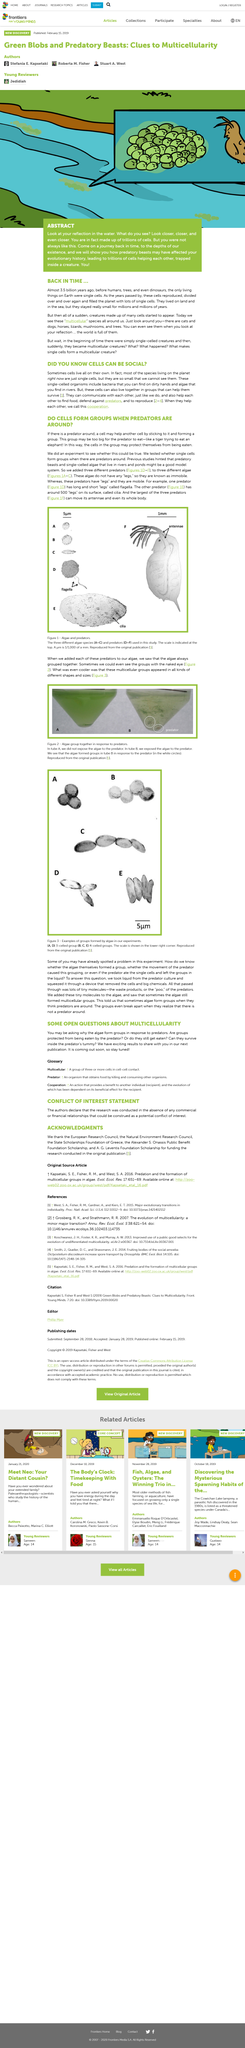Point out several critical features in this image. As depicted in Figure 1, three predators are visually represented. In Figure 1, three different algae species are depicted. The groups break apart when they realize that there is no predator present. The presence of algae forming multicellular groups suggests that they may group together in the presence of perceived predators. Almost 3.5 billion years ago, the only living organisms on Earth were single-celled microorganisms. 